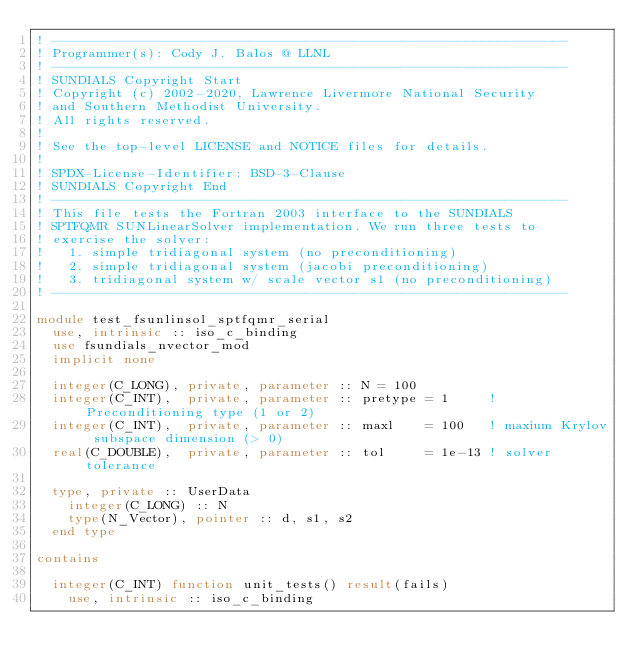Convert code to text. <code><loc_0><loc_0><loc_500><loc_500><_FORTRAN_>! -----------------------------------------------------------------
! Programmer(s): Cody J. Balos @ LLNL
! -----------------------------------------------------------------
! SUNDIALS Copyright Start
! Copyright (c) 2002-2020, Lawrence Livermore National Security
! and Southern Methodist University.
! All rights reserved.
!
! See the top-level LICENSE and NOTICE files for details.
!
! SPDX-License-Identifier: BSD-3-Clause
! SUNDIALS Copyright End
! -----------------------------------------------------------------
! This file tests the Fortran 2003 interface to the SUNDIALS
! SPTFQMR SUNLinearSolver implementation. We run three tests to
! exercise the solver:
!   1. simple tridiagonal system (no preconditioning)
!   2. simple tridiagonal system (jacobi preconditioning)
!   3. tridiagonal system w/ scale vector s1 (no preconditioning)
! -----------------------------------------------------------------

module test_fsunlinsol_sptfqmr_serial
  use, intrinsic :: iso_c_binding
  use fsundials_nvector_mod
  implicit none

  integer(C_LONG), private, parameter :: N = 100
  integer(C_INT),  private, parameter :: pretype = 1     ! Preconditioning type (1 or 2)
  integer(C_INT),  private, parameter :: maxl    = 100   ! maxium Krylov subspace dimension (> 0)
  real(C_DOUBLE),  private, parameter :: tol     = 1e-13 ! solver tolerance

  type, private :: UserData
    integer(C_LONG) :: N
    type(N_Vector), pointer :: d, s1, s2
  end type

contains

  integer(C_INT) function unit_tests() result(fails)
    use, intrinsic :: iso_c_binding</code> 